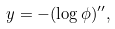<formula> <loc_0><loc_0><loc_500><loc_500>y = - ( \log \phi ) ^ { \prime \prime } ,</formula> 